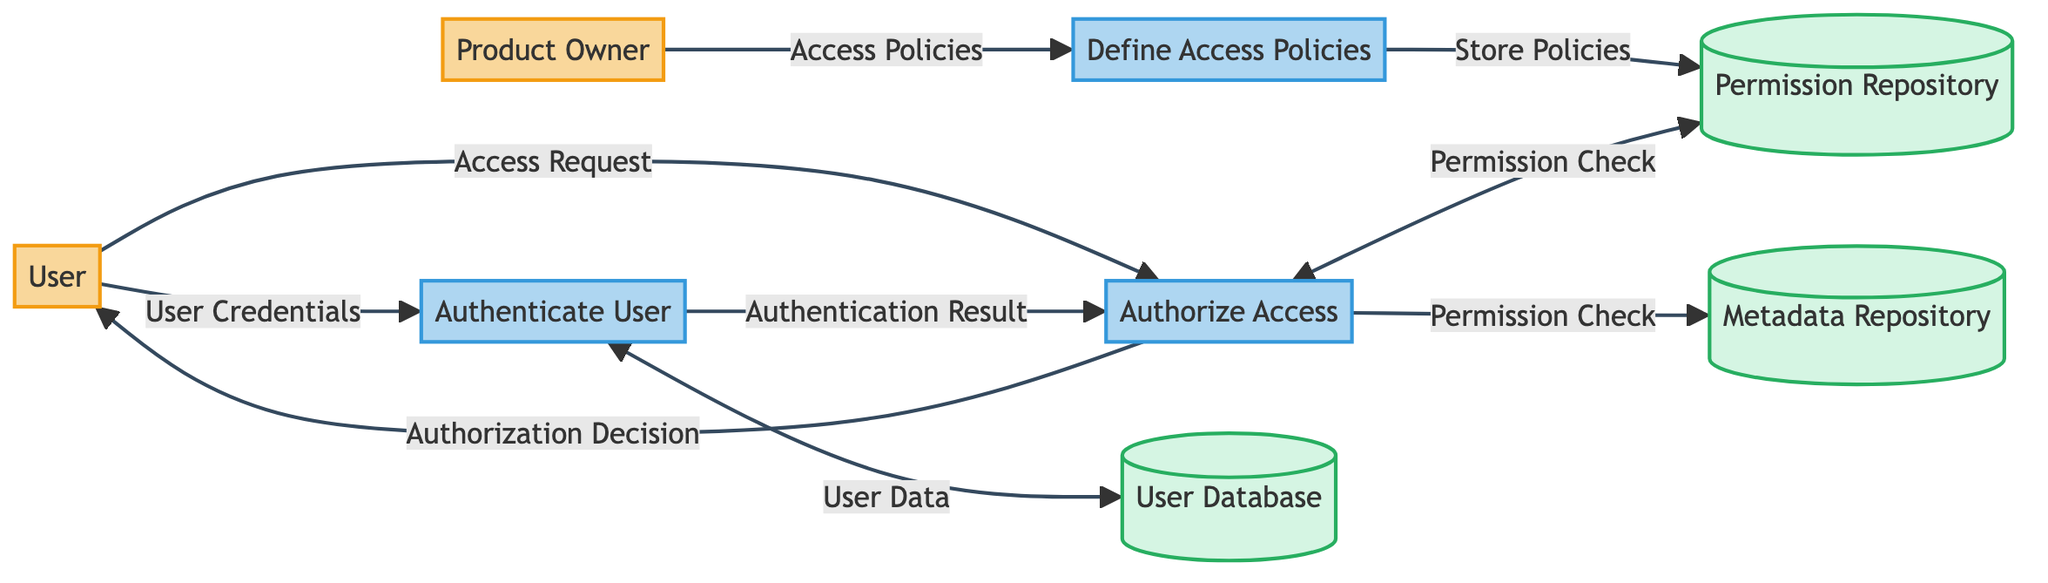What is the first process in the diagram? The first process listed in the diagram is "Define Access Policies". It is the first process node drawn, and it directly receives input from the external entity "Product Owner".
Answer: Define Access Policies How many data stores are present in the diagram? The diagram contains three data stores. They are "User Database", "Permission Repository", and "Metadata Repository". This can be counted by identifying the symbols representing data stores in the diagram.
Answer: Three What flows user credentials to the Authenticate User process? The flow that sends user credentials to "Authenticate User" is labeled "User Credentials". This can be found as the linkage from the "User" external entity to the "Authenticate User" process.
Answer: User Credentials What is the final output from the Authorize Access process? The final output from "Authorize Access" is labeled "Authorization Decision". This flow goes to the external entity "User", indicating the process results.
Answer: Authorization Decision Which entity provides access policies to the Define Access Policies process? The entity that provides access policies to the "Define Access Policies" process is the "Product Owner". The flow is indicated by the arrow connecting the "Product Owner" to the "Define Access Policies".
Answer: Product Owner What is the relationship between Authenticate User and User Database? The relationship is that "Authenticate User" accepts user data from "User Database". The interaction is bidirectional as "Authenticate" both receives and validates using the credentials stored in "User Database".
Answer: User data What is the purpose of the Permission Repository data store? The purpose of the "Permission Repository" is to store access policies and permissions. This is directly stated in the description of the "Permission Repository" data store.
Answer: Store access policies and permissions What flow indicates if the user authentication was successful? The flow indicating if the user authentication was successful is labeled "Authentication Result." This is the flow from "Authenticate User" to "Authorize Access" that conveys the result of the authentication process.
Answer: Authentication Result Which process checks user permissions? The process that checks user permissions is "Authorize Access". This can be determined by following the flow from "Authorize Access" to the "Permission Repository" where permissions are verified.
Answer: Authorize Access 